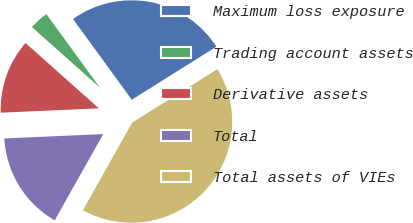Convert chart. <chart><loc_0><loc_0><loc_500><loc_500><pie_chart><fcel>Maximum loss exposure<fcel>Trading account assets<fcel>Derivative assets<fcel>Total<fcel>Total assets of VIEs<nl><fcel>26.1%<fcel>3.4%<fcel>12.28%<fcel>16.15%<fcel>42.06%<nl></chart> 